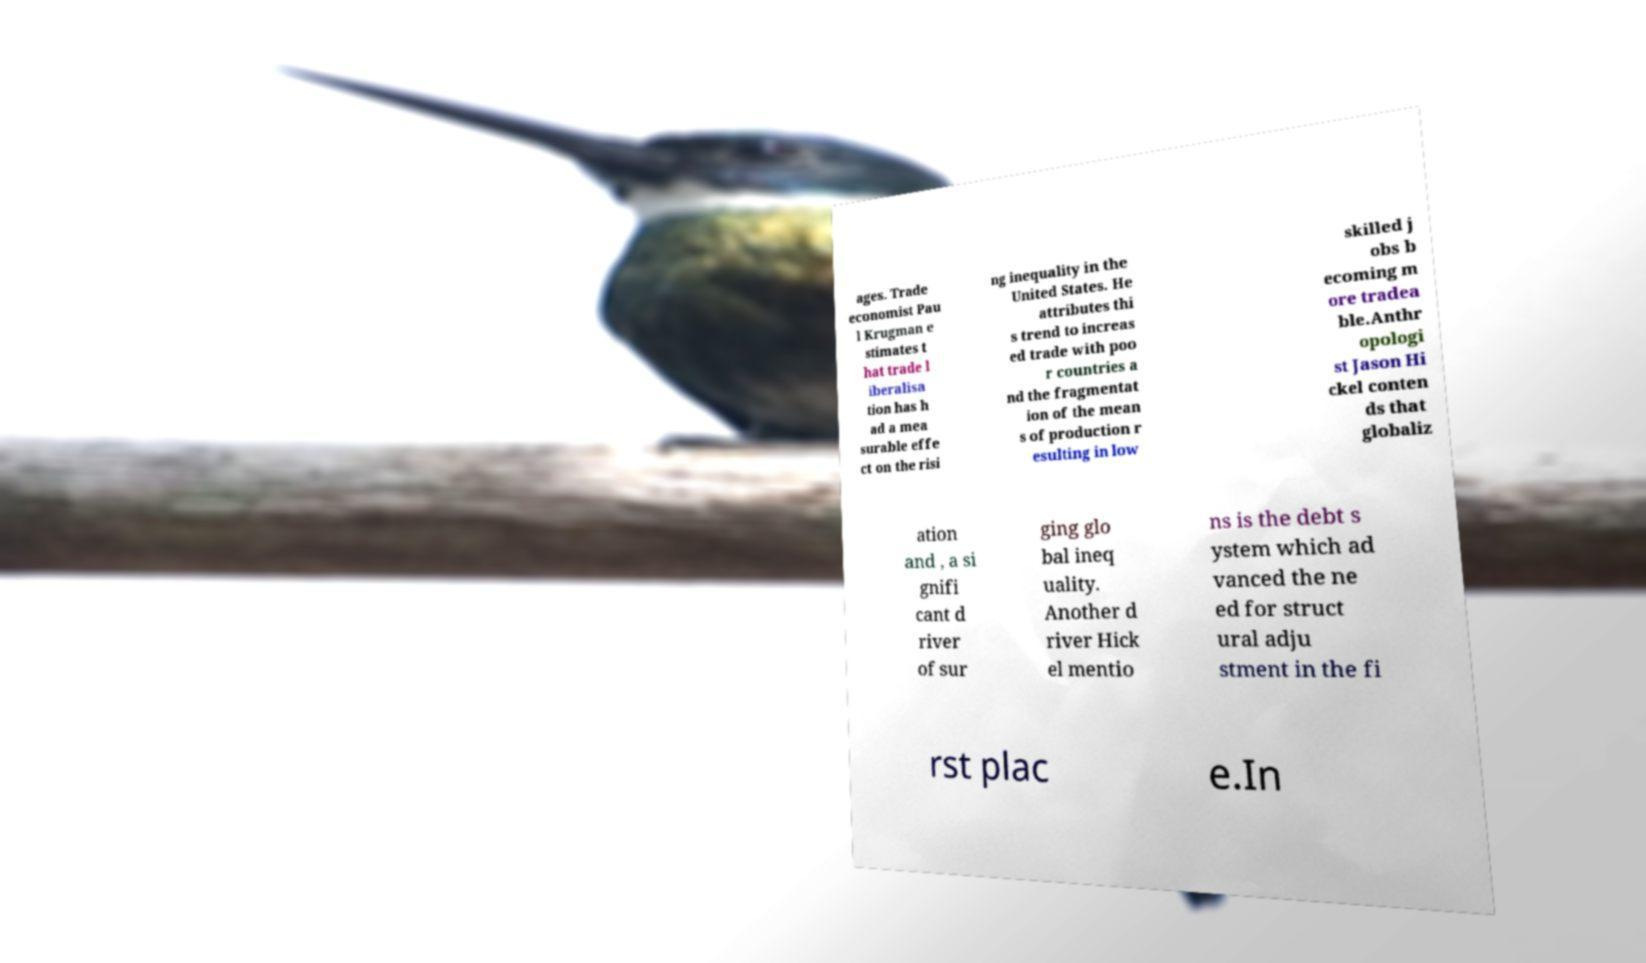Please identify and transcribe the text found in this image. ages. Trade economist Pau l Krugman e stimates t hat trade l iberalisa tion has h ad a mea surable effe ct on the risi ng inequality in the United States. He attributes thi s trend to increas ed trade with poo r countries a nd the fragmentat ion of the mean s of production r esulting in low skilled j obs b ecoming m ore tradea ble.Anthr opologi st Jason Hi ckel conten ds that globaliz ation and , a si gnifi cant d river of sur ging glo bal ineq uality. Another d river Hick el mentio ns is the debt s ystem which ad vanced the ne ed for struct ural adju stment in the fi rst plac e.In 